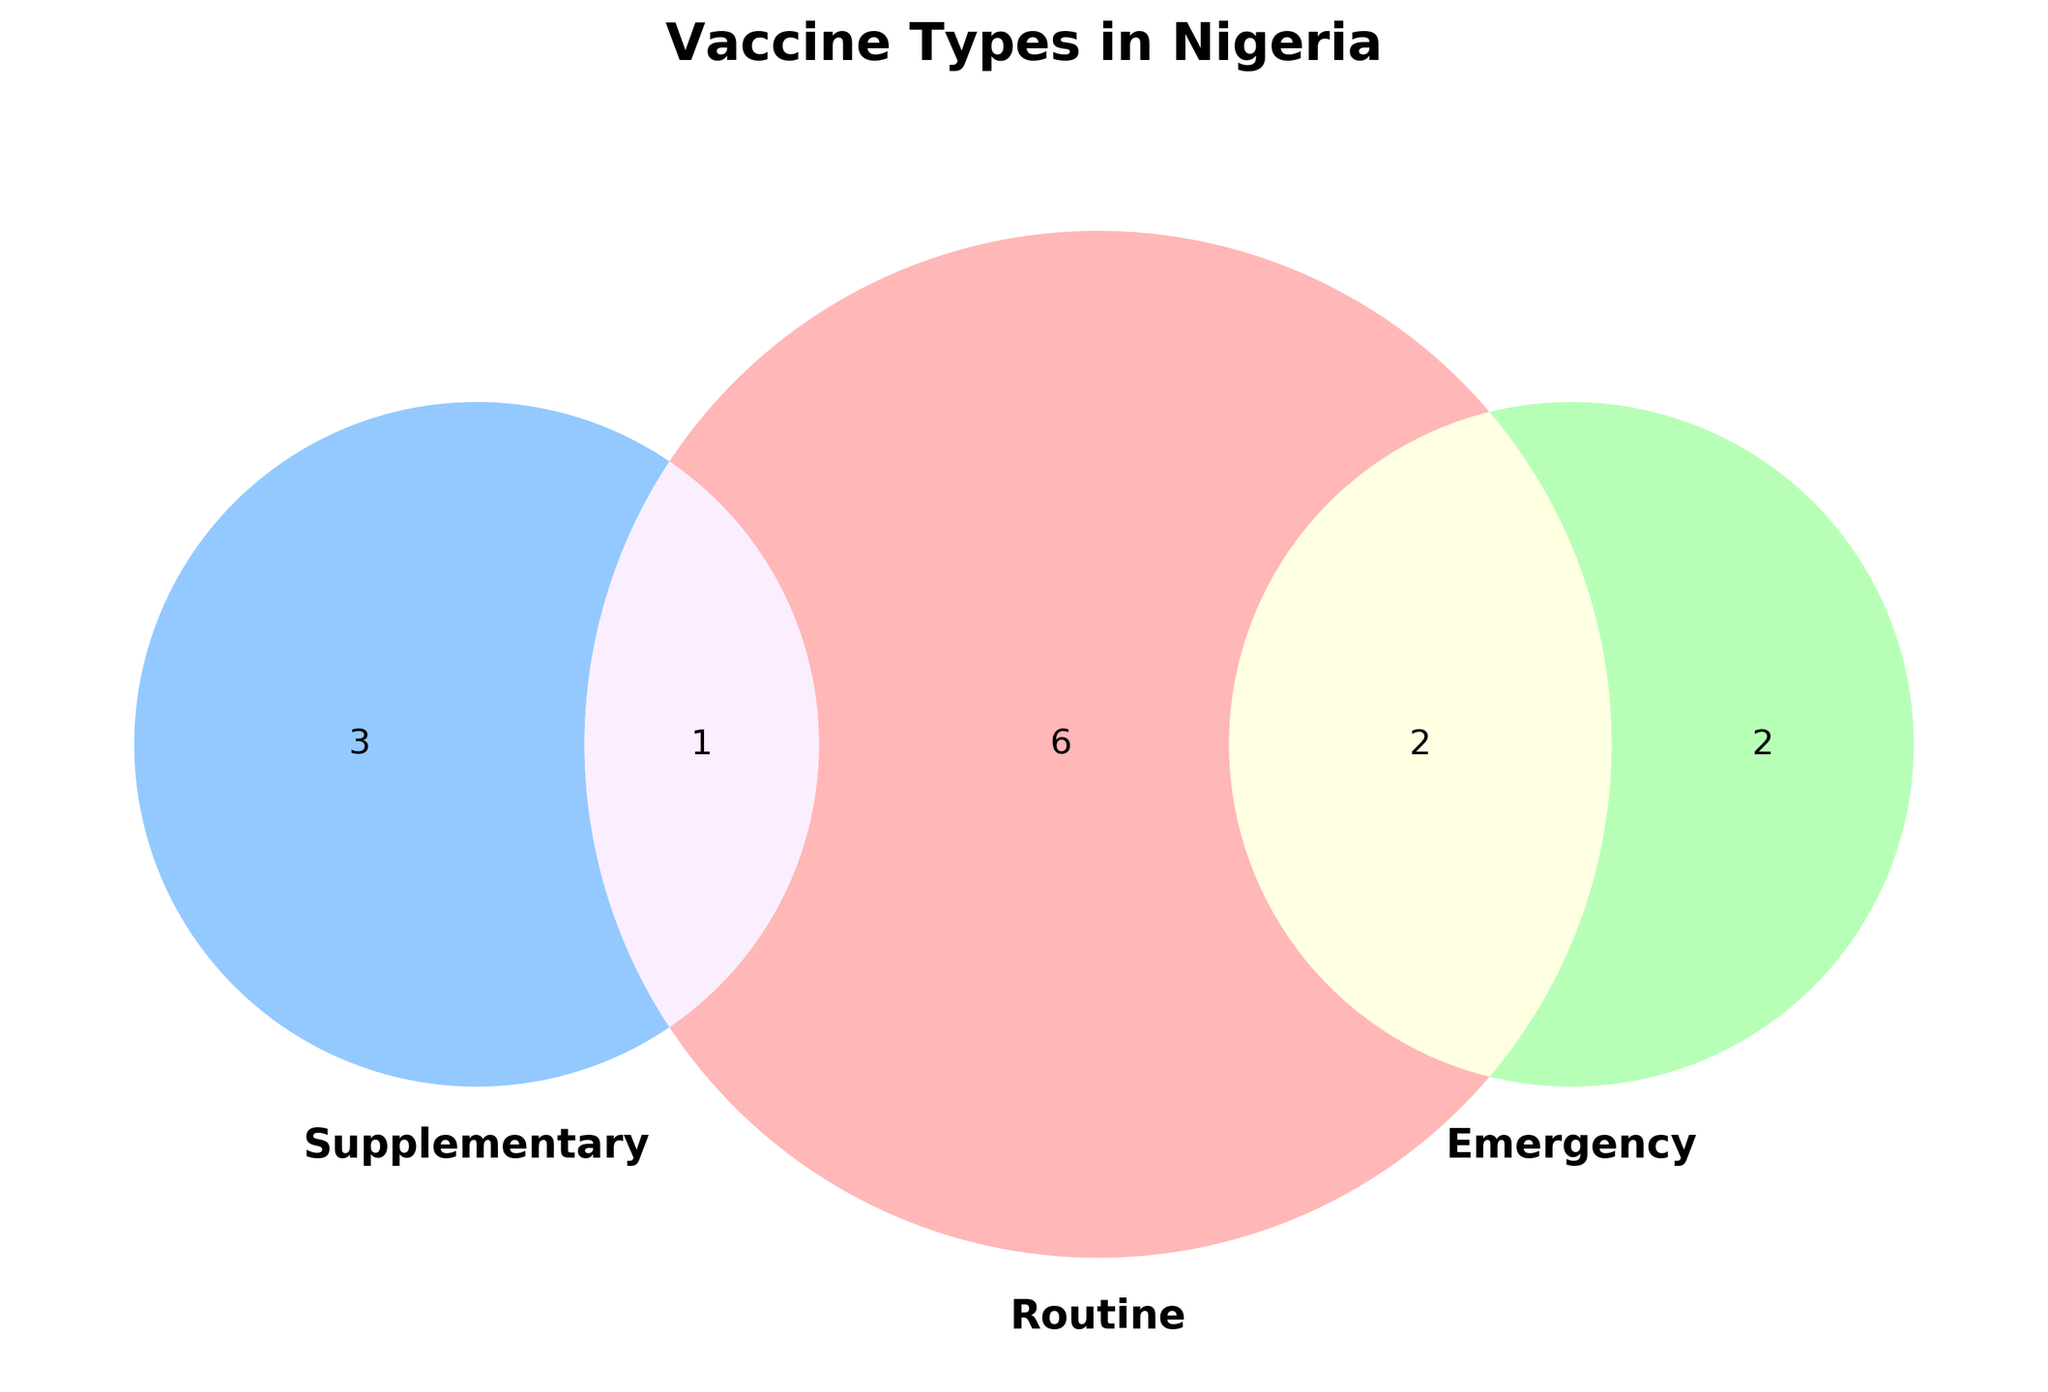What's the title of the Venn diagram? The title is displayed at the top of the figure and is typically the largest text.
Answer: Vaccine Types in Nigeria Which categories of vaccines overlap with three or more types? Look for sections of the Venn diagram where the sets overlap. The diagram shows multiple types in Routine and Emergency overlap with other sets.
Answer: Routine, Emergency How many vaccines are exclusive to the "Supplementary" category? In a Venn diagram, the sections that represent exclusive membership are on the non-overlapping periphery of a set.
Answer: 1 Which vaccines fall into both "Routine" and "Emergency" categories? Check the overlap area where "Routine" and "Emergency" sets intersect and list the vaccine names noted there.
Answer: Polio, Tetanus Which vaccine type is found in all three categories: Routine, Supplementary, and Emergency? Look for a single name that appears in the intersection of the three sets. The Venn diagram should show this clearly.
Answer: None How many vaccine types fall only under "Routine" but not in other categories? Count the segments in the Venn diagram that are exclusively colored for the Routine category, not overlapping with other categories.
Answer: 6 What's the total number of vaccines in these three categories? Sum the total number of unique vaccine types displayed in the Venn diagram irrespective of overlap.  Count each vaccine type once.
Answer: 14 Are there more vaccines in the "Routine" category alone or jointly in "Routine" and "Supplementary"? Compare the segment only in "Routine" with the segment shared between "Routine" and "Supplementary".
Answer: Routine alone How many vaccines fall under both "Routine" and "Supplementary" categories but not "Emergency"? Identify the overlap section between "Routine" and "Supplementary" that doesn't intersect "Emergency".
Answer: 1 Which type of vaccines overlaps across both Supplementary and Emergency categories? Examine the intersecting area of "Supplementary" and "Emergency" in the Venn diagram and mention the vaccine type(s) listed.
Answer: None 